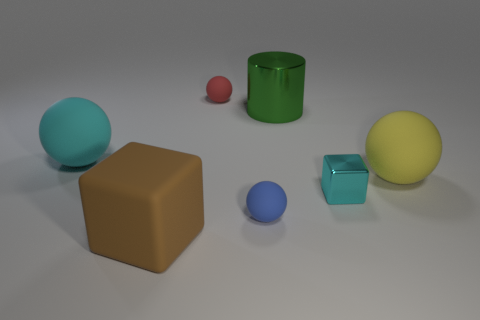Add 3 green metal cylinders. How many objects exist? 10 Subtract all cyan blocks. How many blocks are left? 1 Subtract all spheres. How many objects are left? 3 Subtract 1 blocks. How many blocks are left? 1 Add 4 big objects. How many big objects are left? 8 Add 3 big red metal cylinders. How many big red metal cylinders exist? 3 Subtract 1 yellow spheres. How many objects are left? 6 Subtract all brown spheres. Subtract all gray cylinders. How many spheres are left? 4 Subtract all blue cylinders. How many green cubes are left? 0 Subtract all small red shiny cubes. Subtract all cyan shiny objects. How many objects are left? 6 